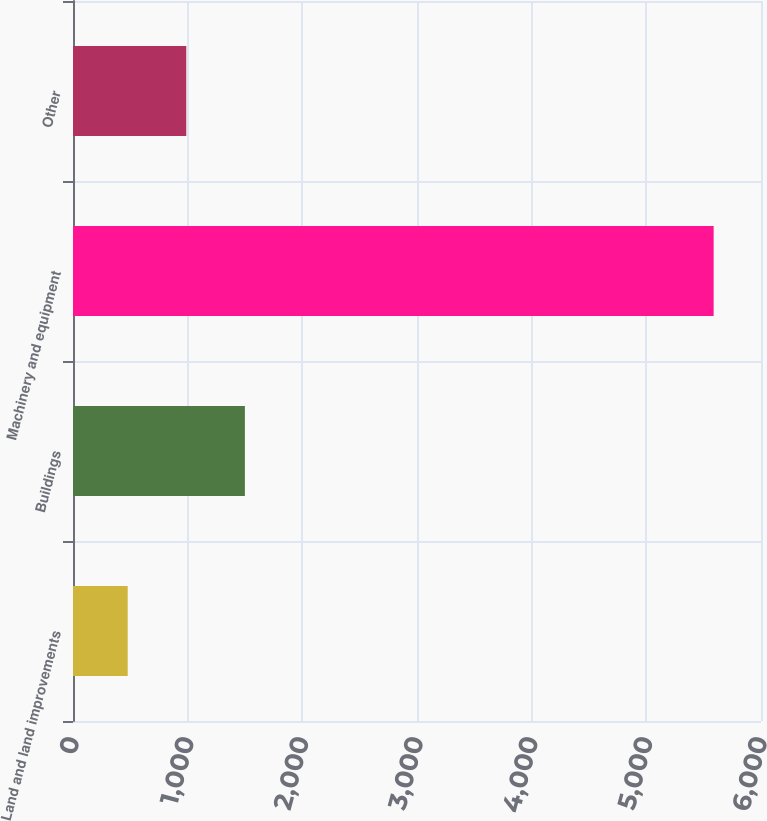Convert chart. <chart><loc_0><loc_0><loc_500><loc_500><bar_chart><fcel>Land and land improvements<fcel>Buildings<fcel>Machinery and equipment<fcel>Other<nl><fcel>477<fcel>1499<fcel>5587<fcel>988<nl></chart> 